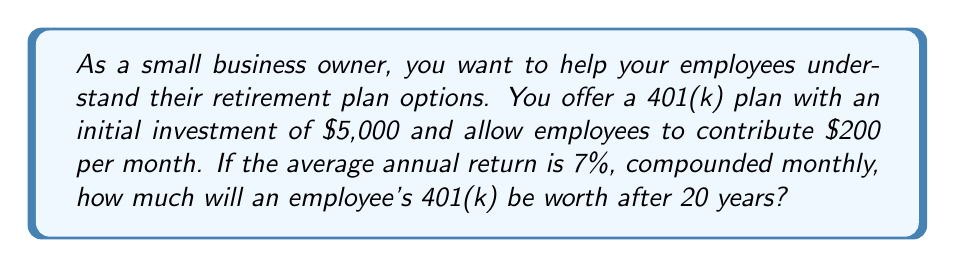Could you help me with this problem? To solve this problem, we'll use the compound interest formula for regular contributions:

$$A = P(1 + \frac{r}{n})^{nt} + PMT \cdot \frac{(1 + \frac{r}{n})^{nt} - 1}{\frac{r}{n}}$$

Where:
$A$ = Final amount
$P$ = Initial principal balance
$r$ = Annual interest rate (as a decimal)
$n$ = Number of times interest is compounded per year
$t$ = Number of years
$PMT$ = Regular payment amount

Given:
$P = \$5,000$
$r = 0.07$ (7% annual return)
$n = 12$ (compounded monthly)
$t = 20$ years
$PMT = \$200$ (monthly contribution)

Let's substitute these values into the formula:

$$A = 5000(1 + \frac{0.07}{12})^{12 \cdot 20} + 200 \cdot \frac{(1 + \frac{0.07}{12})^{12 \cdot 20} - 1}{\frac{0.07}{12}}$$

Simplifying:

$$A = 5000(1 + 0.005833)^{240} + 200 \cdot \frac{(1 + 0.005833)^{240} - 1}{0.005833}$$

Using a calculator or spreadsheet to compute this:

$$A = 5000 \cdot 3.87 + 200 \cdot 477.69$$
$$A = 19,350 + 95,538$$
$$A = 114,888$$

Rounding to the nearest dollar, the final amount is $114,888.
Answer: $114,888 